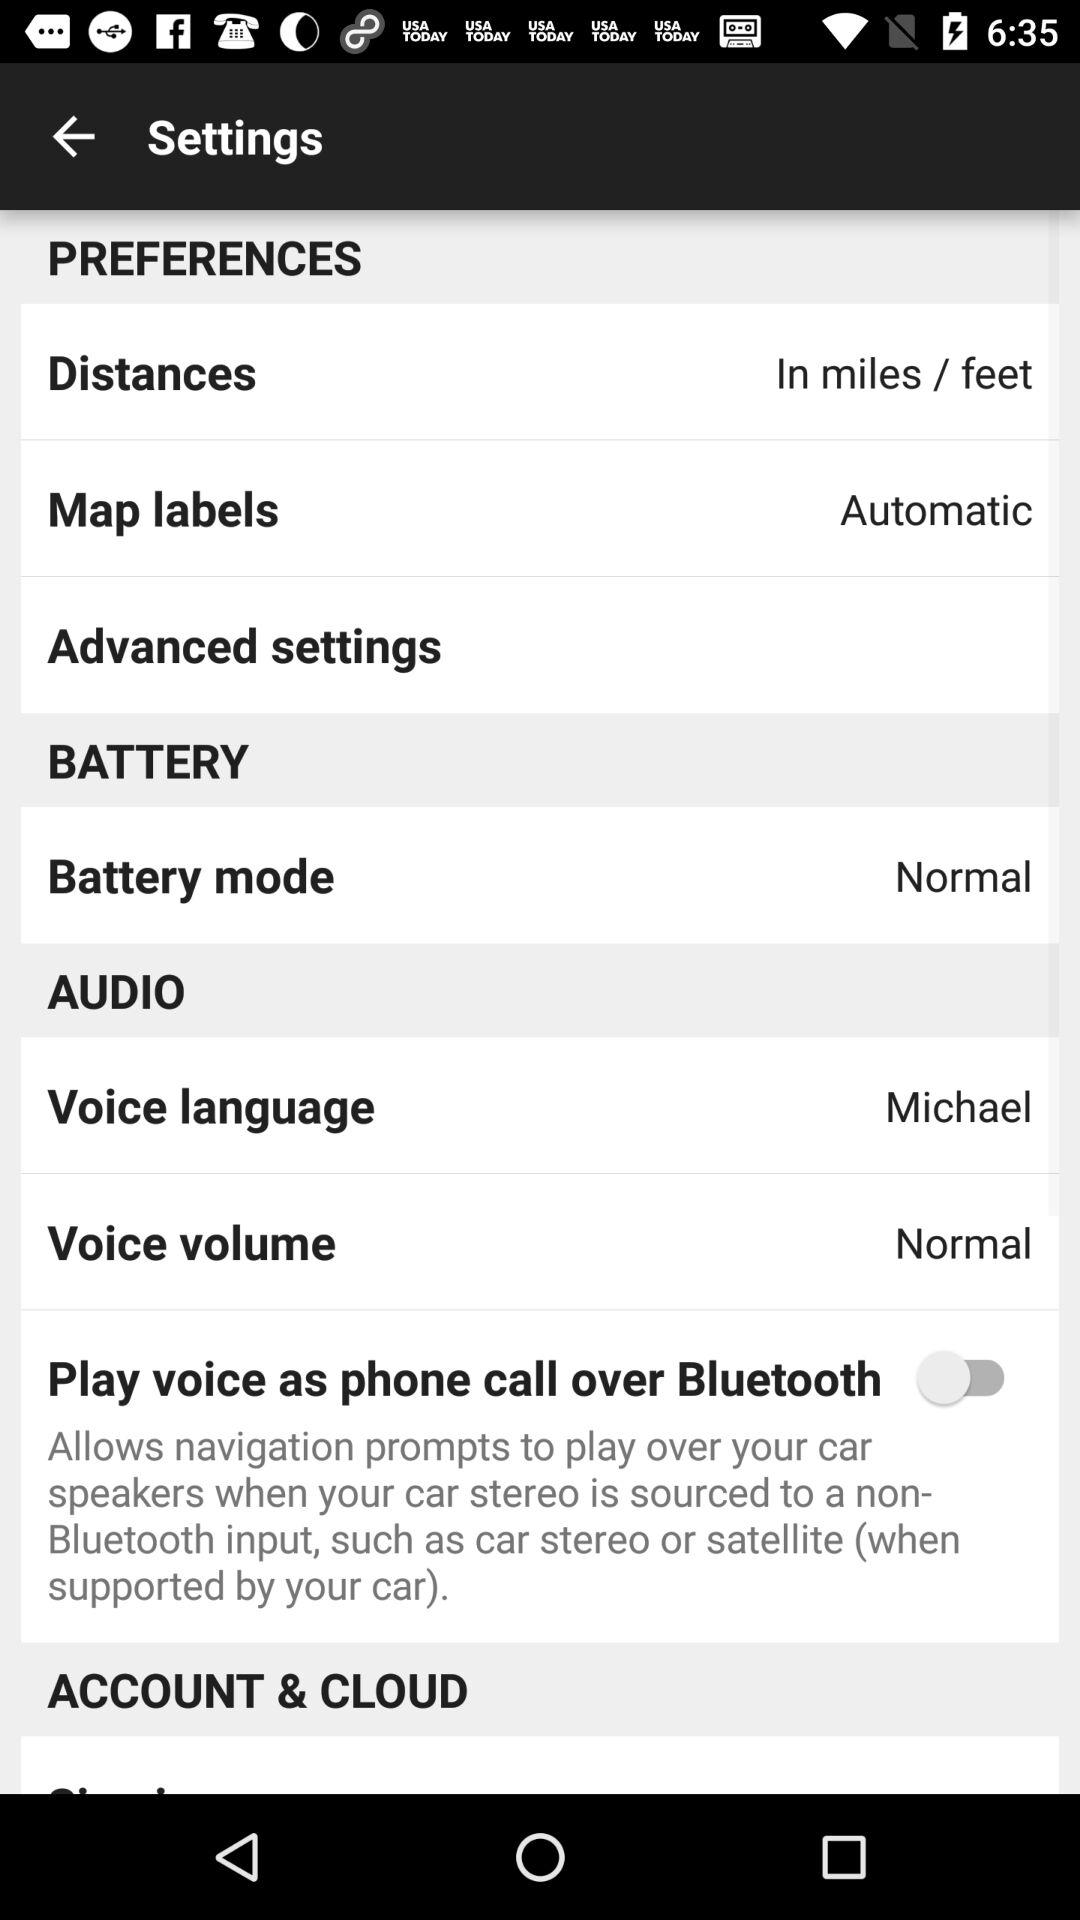What is the status of "Play voice as phone call over Bluetooth"? The status is "off". 